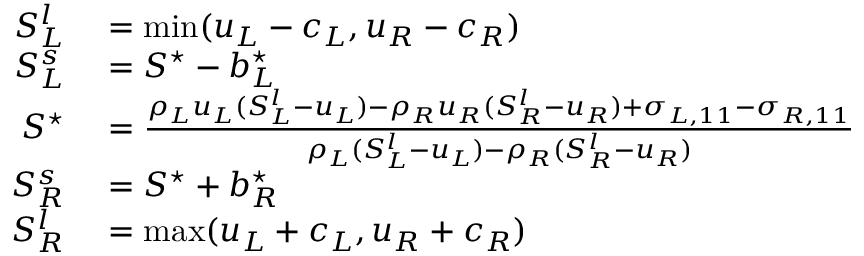<formula> <loc_0><loc_0><loc_500><loc_500>\begin{array} { r l } { S _ { L } ^ { l } } & = \min ( u _ { L } - c _ { L } , u _ { R } - c _ { R } ) } \\ { S _ { L } ^ { s } } & = S ^ { ^ { * } } - b _ { L } ^ { ^ { * } } } \\ { S ^ { ^ { * } } } & = \frac { \rho _ { L } u _ { L } ( S _ { L } ^ { l } - u _ { L } ) - \rho _ { R } u _ { R } ( S _ { R } ^ { l } - u _ { R } ) + \sigma _ { L , 1 1 } - \sigma _ { R , 1 1 } } { \rho _ { L } ( S _ { L } ^ { l } - u _ { L } ) - \rho _ { R } ( S _ { R } ^ { l } - u _ { R } ) } } \\ { S _ { R } ^ { s } } & = S ^ { ^ { * } } + b _ { R } ^ { ^ { * } } } \\ { S _ { R } ^ { l } } & = \max ( u _ { L } + c _ { L } , u _ { R } + c _ { R } ) } \end{array}</formula> 